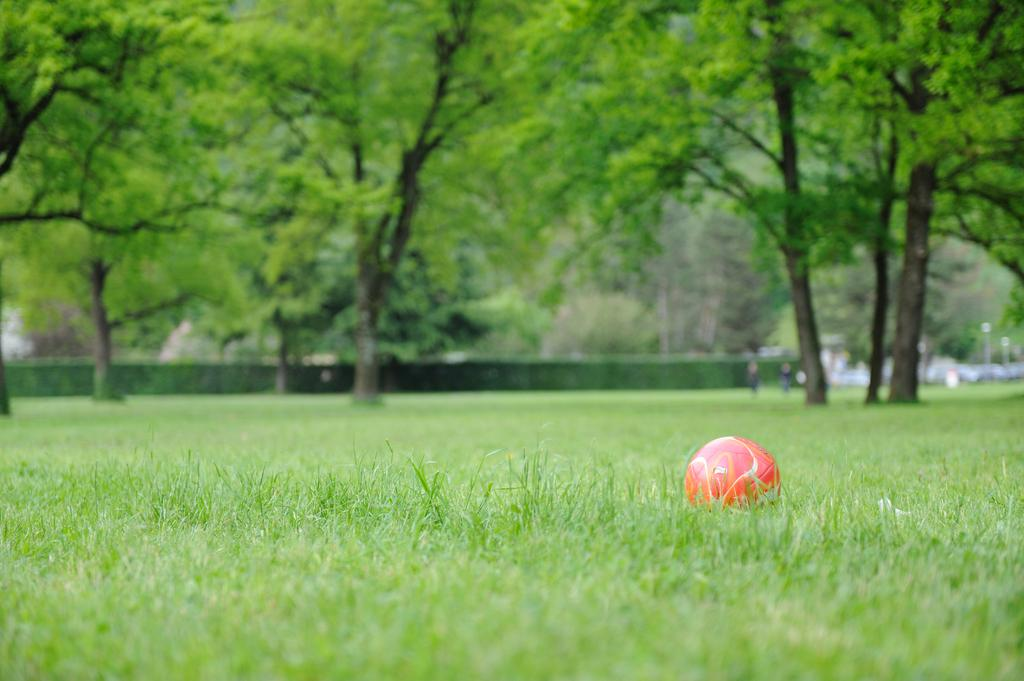What is located on the grass in the image? There is a ball on the grass. What can be seen in the background of the image? There are trees, two people, poles, and some unspecified objects in the background of the image. Can you describe the quality of the image? The image is blurry. What type of pie is being served on the train in the image? There is no pie or train present in the image; it features a ball on the grass and various elements in the background. 